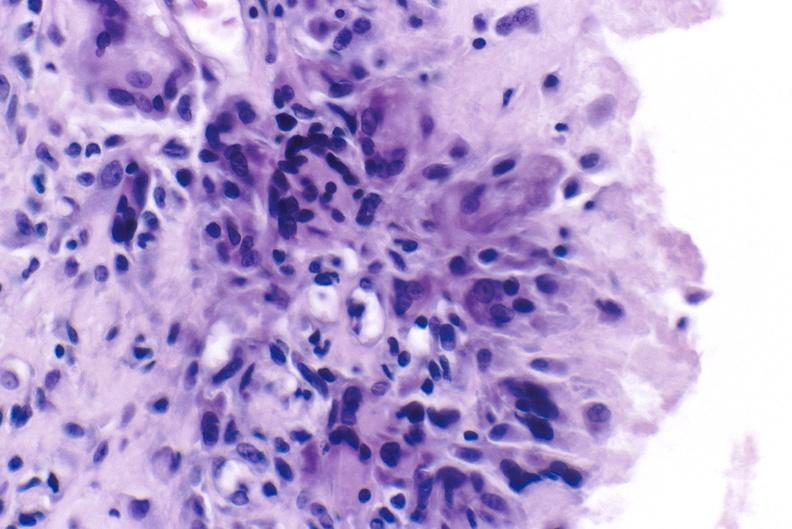s varices present?
Answer the question using a single word or phrase. No 